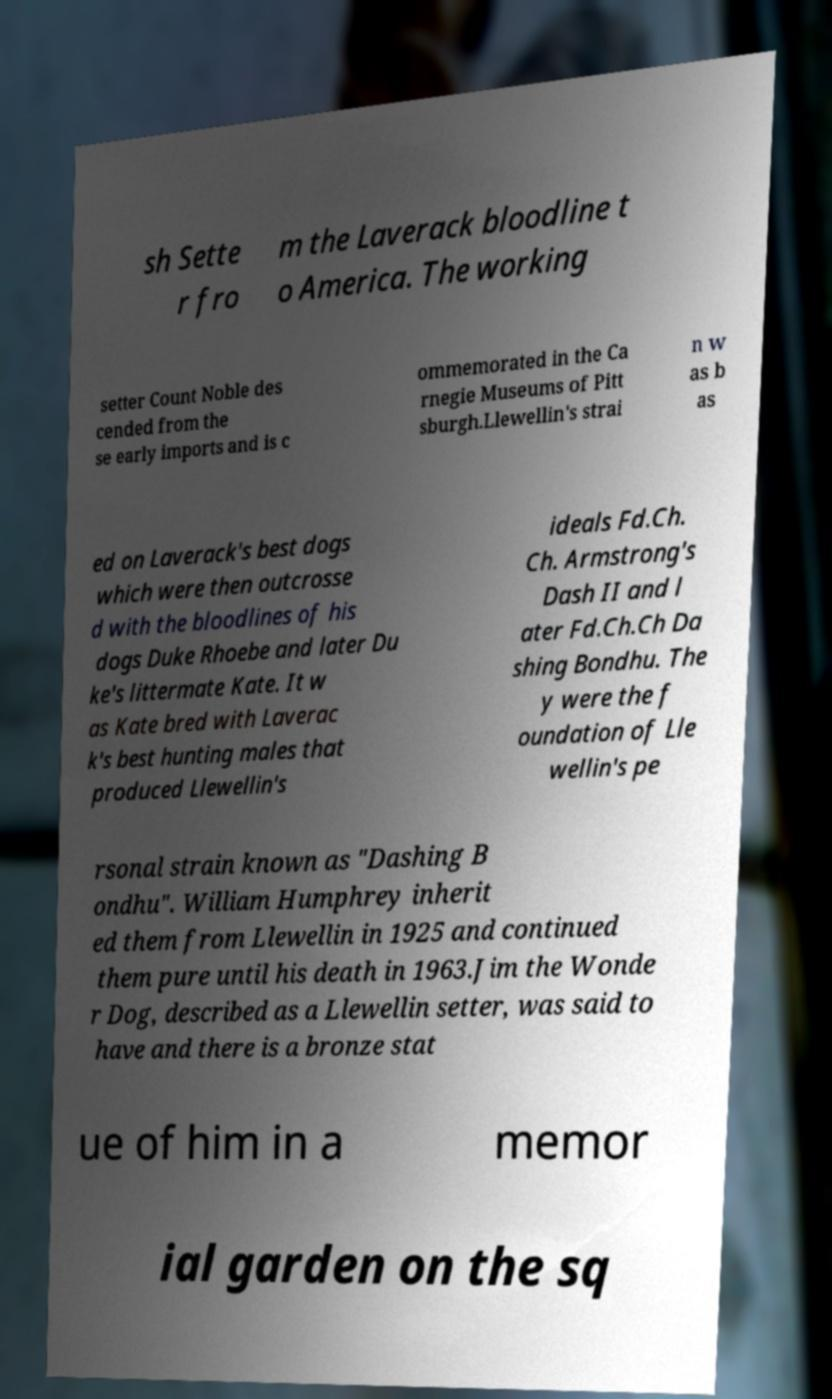Please read and relay the text visible in this image. What does it say? sh Sette r fro m the Laverack bloodline t o America. The working setter Count Noble des cended from the se early imports and is c ommemorated in the Ca rnegie Museums of Pitt sburgh.Llewellin's strai n w as b as ed on Laverack's best dogs which were then outcrosse d with the bloodlines of his dogs Duke Rhoebe and later Du ke's littermate Kate. It w as Kate bred with Laverac k's best hunting males that produced Llewellin's ideals Fd.Ch. Ch. Armstrong's Dash II and l ater Fd.Ch.Ch Da shing Bondhu. The y were the f oundation of Lle wellin's pe rsonal strain known as "Dashing B ondhu". William Humphrey inherit ed them from Llewellin in 1925 and continued them pure until his death in 1963.Jim the Wonde r Dog, described as a Llewellin setter, was said to have and there is a bronze stat ue of him in a memor ial garden on the sq 